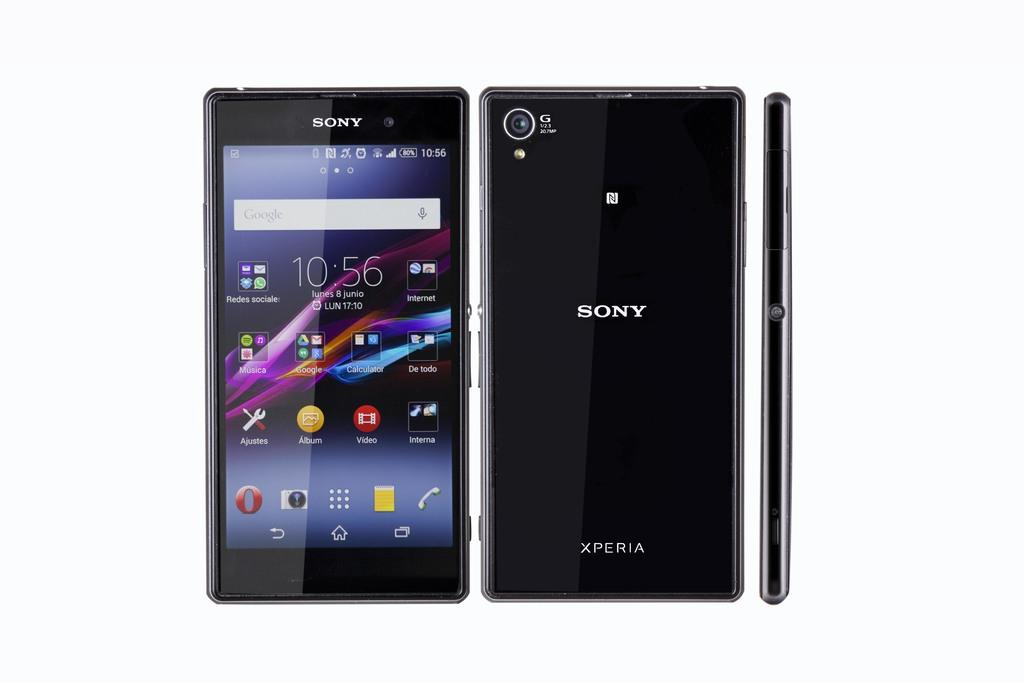<image>
Create a compact narrative representing the image presented. A black Sony phone from three different angles. 